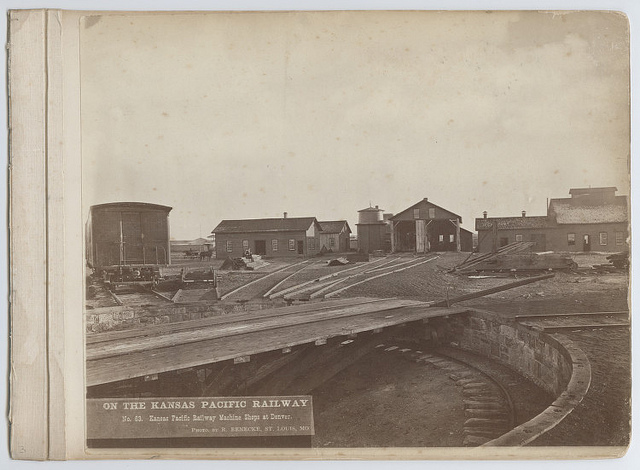Please transcribe the text information in this image. ON THE KANSAS PACIFIC RAILWAY 